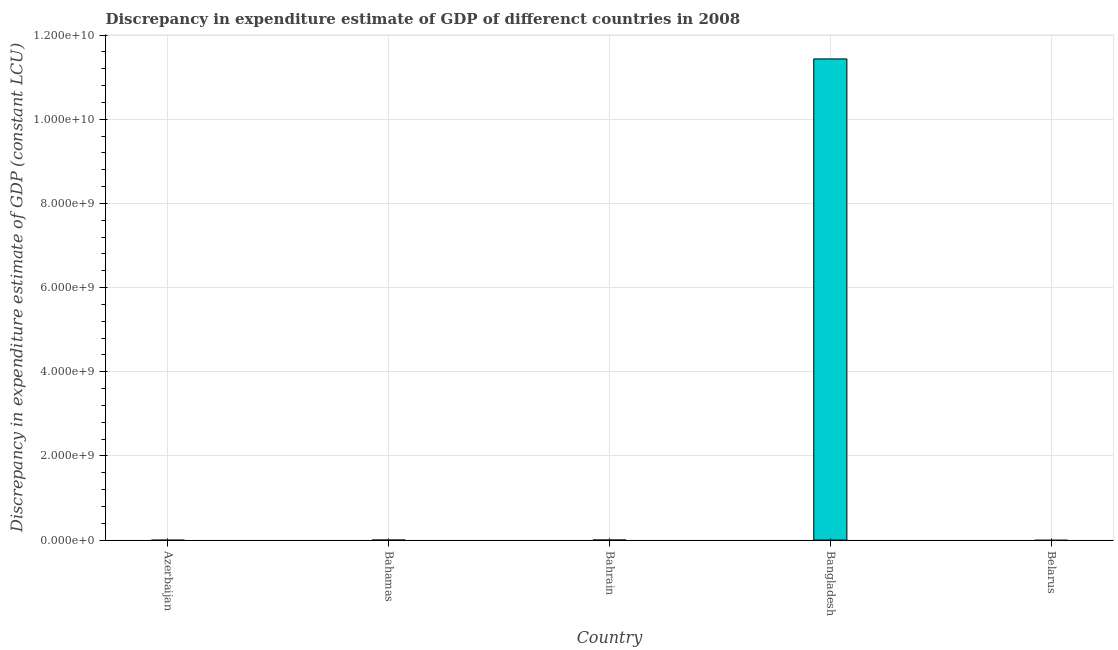Does the graph contain grids?
Offer a very short reply. Yes. What is the title of the graph?
Provide a short and direct response. Discrepancy in expenditure estimate of GDP of differenct countries in 2008. What is the label or title of the Y-axis?
Ensure brevity in your answer.  Discrepancy in expenditure estimate of GDP (constant LCU). What is the discrepancy in expenditure estimate of gdp in Azerbaijan?
Your answer should be very brief. 0. Across all countries, what is the maximum discrepancy in expenditure estimate of gdp?
Provide a succinct answer. 1.14e+1. What is the sum of the discrepancy in expenditure estimate of gdp?
Give a very brief answer. 1.14e+1. What is the difference between the discrepancy in expenditure estimate of gdp in Bahrain and Bangladesh?
Your answer should be compact. -1.14e+1. What is the average discrepancy in expenditure estimate of gdp per country?
Provide a succinct answer. 2.29e+09. What is the median discrepancy in expenditure estimate of gdp?
Your answer should be compact. 0. In how many countries, is the discrepancy in expenditure estimate of gdp greater than 3600000000 LCU?
Provide a succinct answer. 1. Is the difference between the discrepancy in expenditure estimate of gdp in Bahrain and Bangladesh greater than the difference between any two countries?
Ensure brevity in your answer.  No. What is the difference between the highest and the lowest discrepancy in expenditure estimate of gdp?
Your answer should be compact. 1.14e+1. In how many countries, is the discrepancy in expenditure estimate of gdp greater than the average discrepancy in expenditure estimate of gdp taken over all countries?
Your answer should be compact. 1. How many bars are there?
Provide a short and direct response. 2. Are all the bars in the graph horizontal?
Give a very brief answer. No. What is the Discrepancy in expenditure estimate of GDP (constant LCU) in Bahrain?
Give a very brief answer. 8.30e+05. What is the Discrepancy in expenditure estimate of GDP (constant LCU) of Bangladesh?
Make the answer very short. 1.14e+1. What is the Discrepancy in expenditure estimate of GDP (constant LCU) of Belarus?
Make the answer very short. 0. What is the difference between the Discrepancy in expenditure estimate of GDP (constant LCU) in Bahrain and Bangladesh?
Your answer should be very brief. -1.14e+1. What is the ratio of the Discrepancy in expenditure estimate of GDP (constant LCU) in Bahrain to that in Bangladesh?
Your answer should be very brief. 0. 